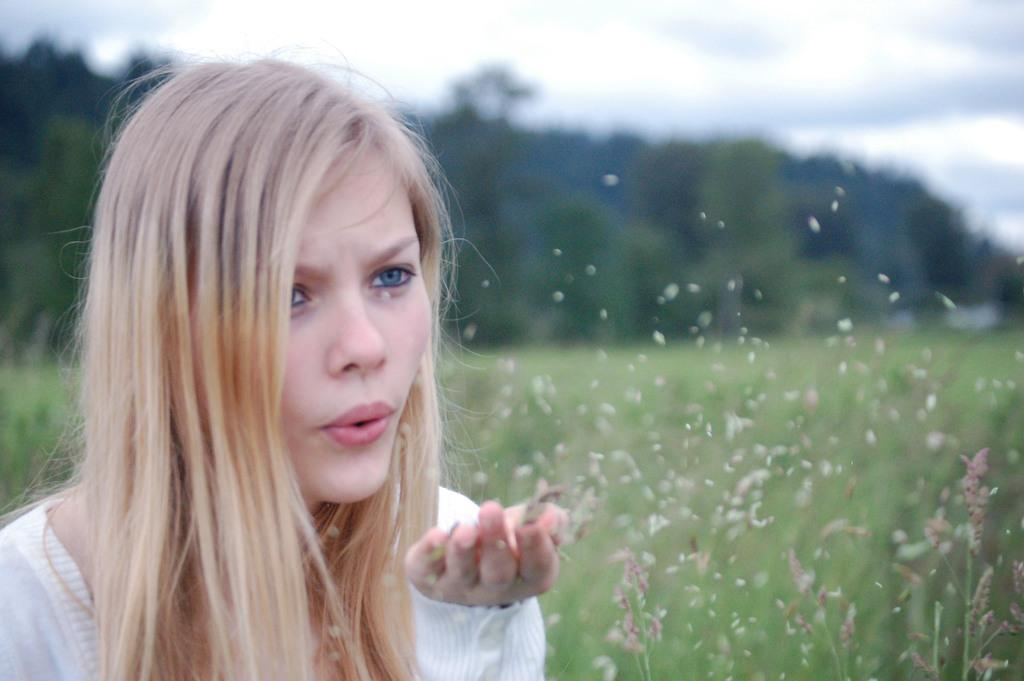What type of vegetation can be seen in the image? There are many trees and green grass in the image. Are there any plants visible in the image? Yes, there are plants in the image. What is the woman in the image holding? The woman is holding wheat in the image. What is the condition of the sky in the image? The sky is cloudy in the image. How many drawers can be seen in the image? There are no drawers present in the image. What type of ants can be seen crawling on the plants in the image? There are no ants visible in the image; it only features trees, grass, plants, a woman holding wheat, and a cloudy sky. 